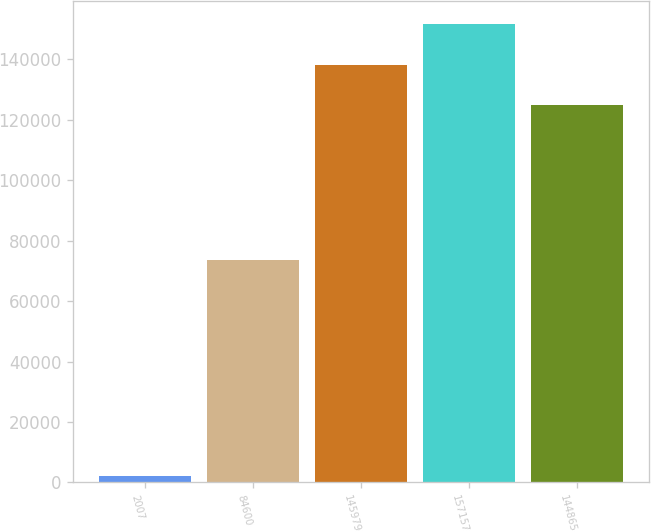Convert chart to OTSL. <chart><loc_0><loc_0><loc_500><loc_500><bar_chart><fcel>2007<fcel>84600<fcel>145979<fcel>157157<fcel>144865<nl><fcel>2007<fcel>73469<fcel>138198<fcel>151529<fcel>124867<nl></chart> 